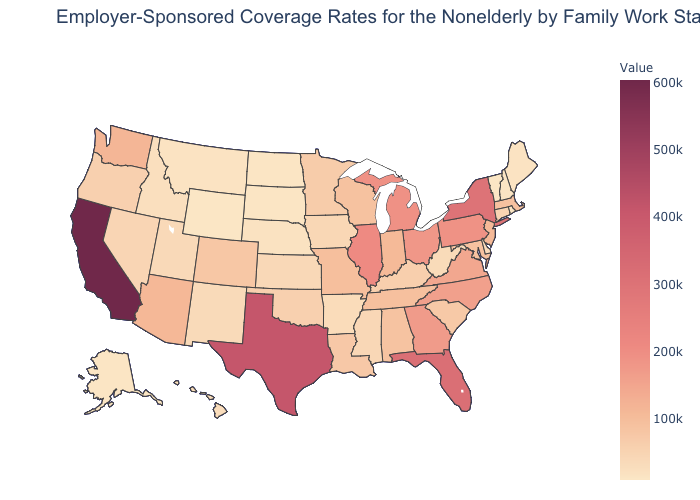Does Washington have the highest value in the West?
Short answer required. No. Does Virginia have the highest value in the South?
Quick response, please. No. Which states have the lowest value in the West?
Short answer required. Wyoming. Does California have the highest value in the USA?
Be succinct. Yes. Does the map have missing data?
Give a very brief answer. No. Does New York have the lowest value in the USA?
Concise answer only. No. Is the legend a continuous bar?
Answer briefly. Yes. 